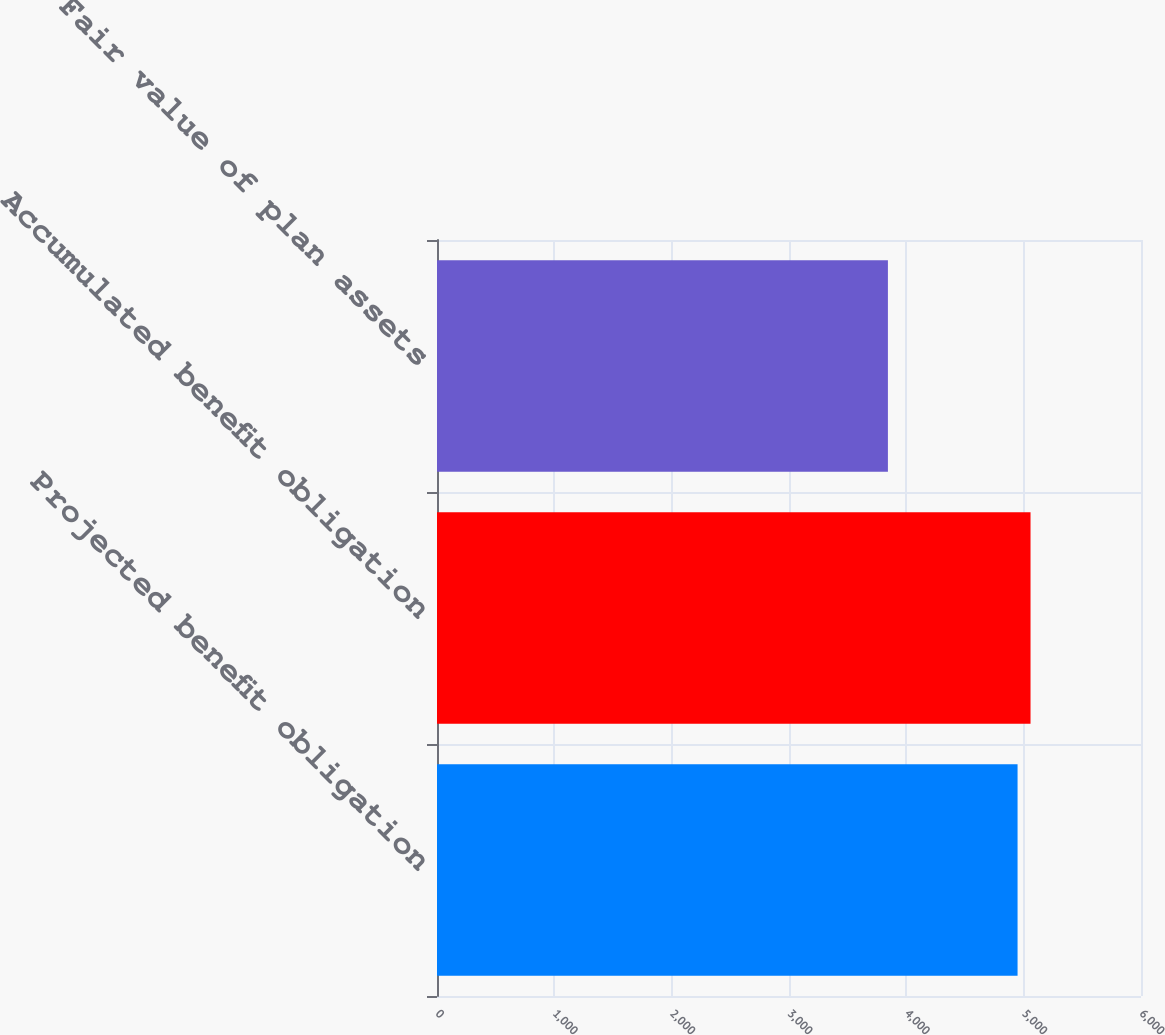Convert chart to OTSL. <chart><loc_0><loc_0><loc_500><loc_500><bar_chart><fcel>Projected benefit obligation<fcel>Accumulated benefit obligation<fcel>Fair value of plan assets<nl><fcel>4948<fcel>5058.5<fcel>3843<nl></chart> 